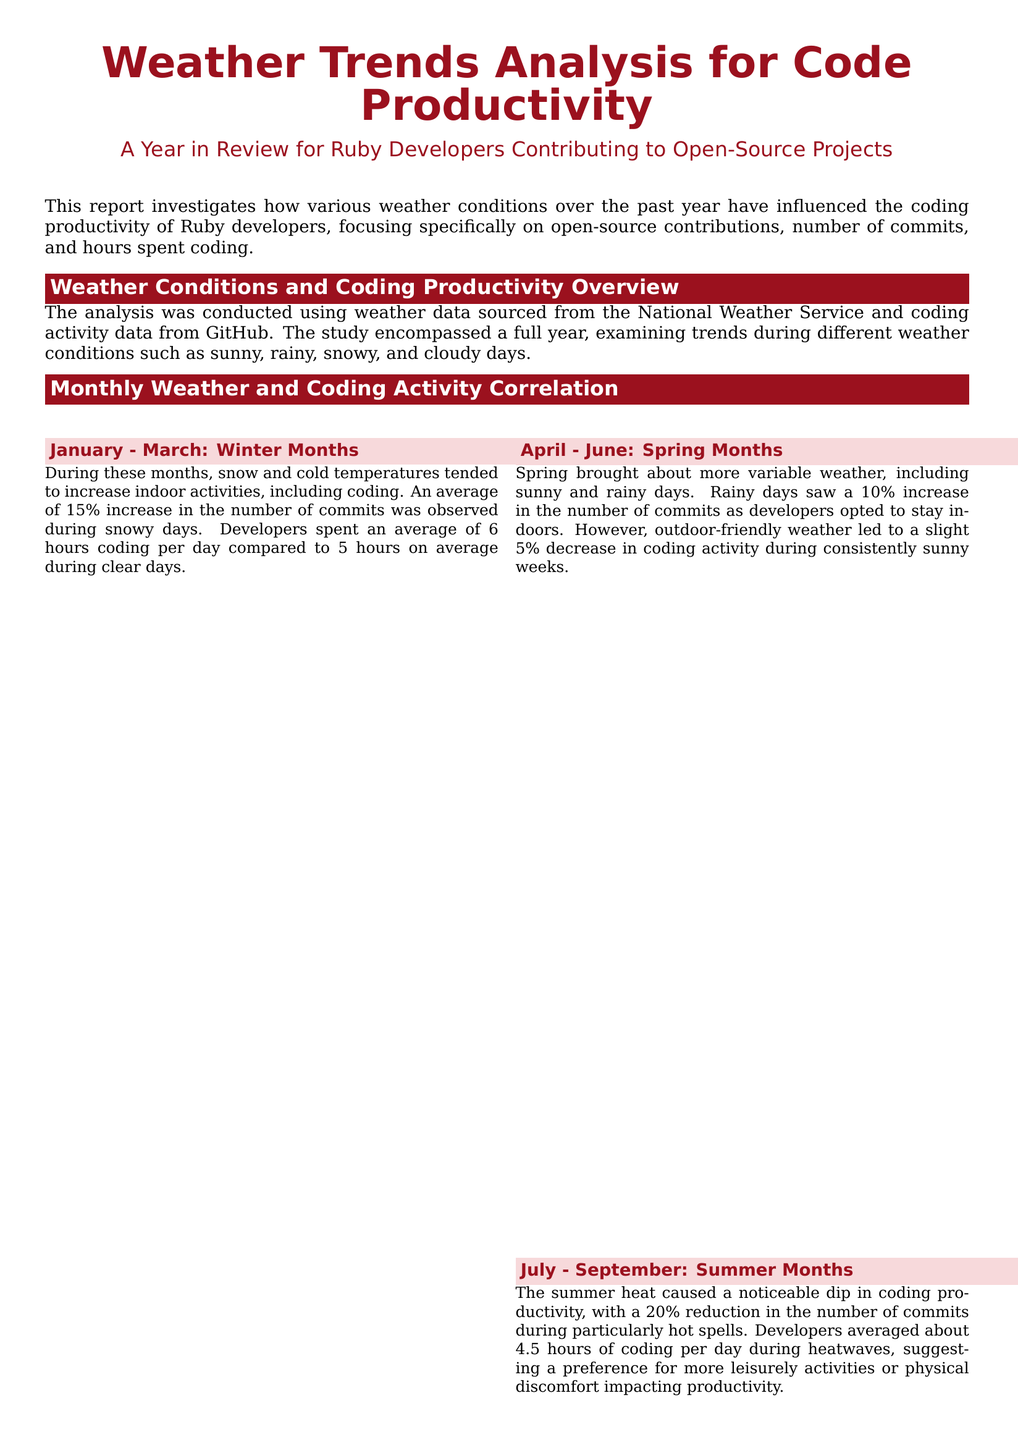what was the average increase in commits during snowy days? The document states that there was an average of 15% increase in the number of commits during snowy days.
Answer: 15% what was the average number of hours spent coding on clear days in winter? The report mentions that developers spent an average of 5 hours coding during clear days in winter.
Answer: 5 hours which open-source project saw significant contributions during winter months? The document highlights that contributions to the 'RSpec' testing suite peaked during winter months.
Answer: RSpec what was the percentage decrease in coding productivity during heatwaves? The analysis notes a 20% reduction in the number of commits during particularly hot spells.
Answer: 20% how many hours did developers spend coding on gloomy days in autumn? The report indicates that developers spent an average of 5.5 hours coding on gloomy days in autumn.
Answer: 5.5 hours what can help maintain high productivity during hot months? The conclusion suggests that using air-conditioned environments can help maintain high productivity during hot months.
Answer: air-conditioned environments during which season did 'Rails' see more activity? The document states that 'Rails' saw more activity in the fall months.
Answer: fall what is the primary focus of this report? The report's main focus is on how various weather conditions have influenced the coding productivity of Ruby developers.
Answer: weather conditions what preference did developers express regarding coding during inclement weather? Developers reported a preference for coding during inclement weather due to fewer distractions.
Answer: fewer distractions 